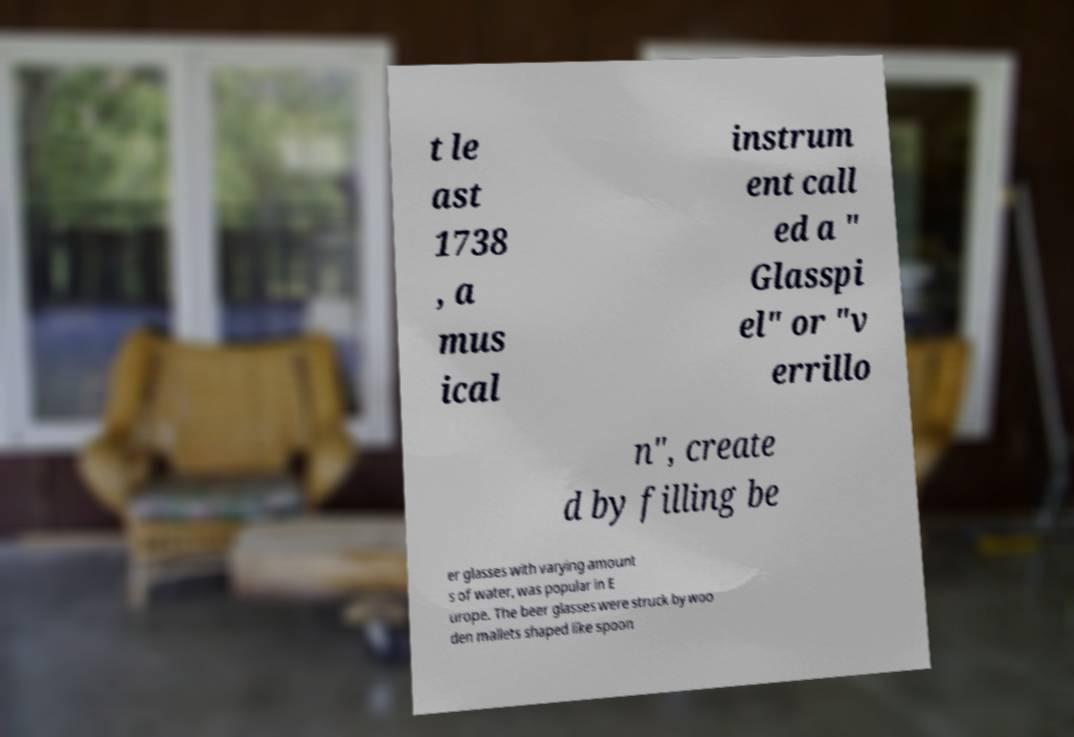Please read and relay the text visible in this image. What does it say? t le ast 1738 , a mus ical instrum ent call ed a " Glasspi el" or "v errillo n", create d by filling be er glasses with varying amount s of water, was popular in E urope. The beer glasses were struck by woo den mallets shaped like spoon 